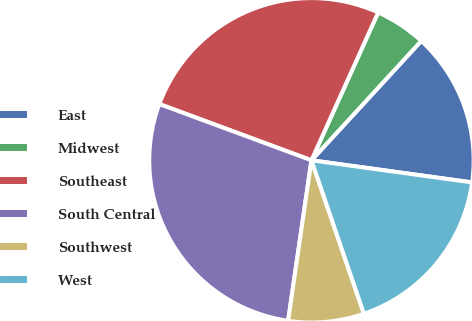<chart> <loc_0><loc_0><loc_500><loc_500><pie_chart><fcel>East<fcel>Midwest<fcel>Southeast<fcel>South Central<fcel>Southwest<fcel>West<nl><fcel>15.34%<fcel>5.09%<fcel>26.11%<fcel>28.34%<fcel>7.54%<fcel>17.58%<nl></chart> 